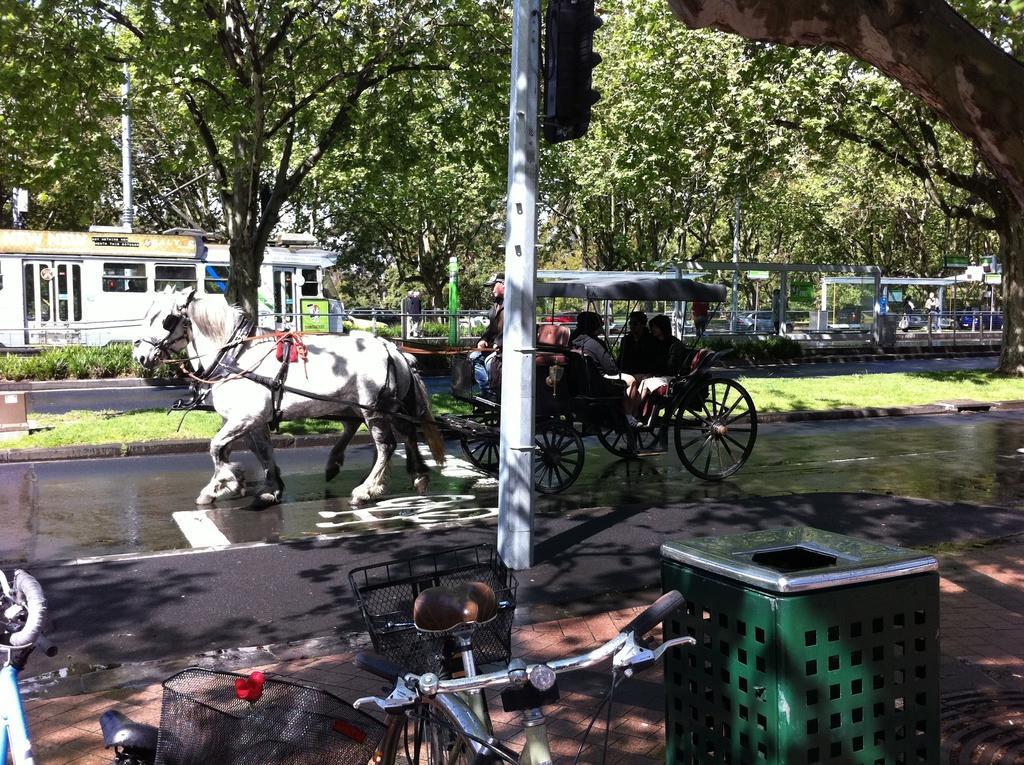In one or two sentences, can you explain what this image depicts? In the middle of the image there is a traffic pole. In the middle of the image few people riding a cart. In the middle of the image there is a horse. Top right side of the image there is a tree. Bottom right side of the image there is a dustbin. Bottom left side of the image there is a bicycle. Top left side of the image there is some bushes and grass. 